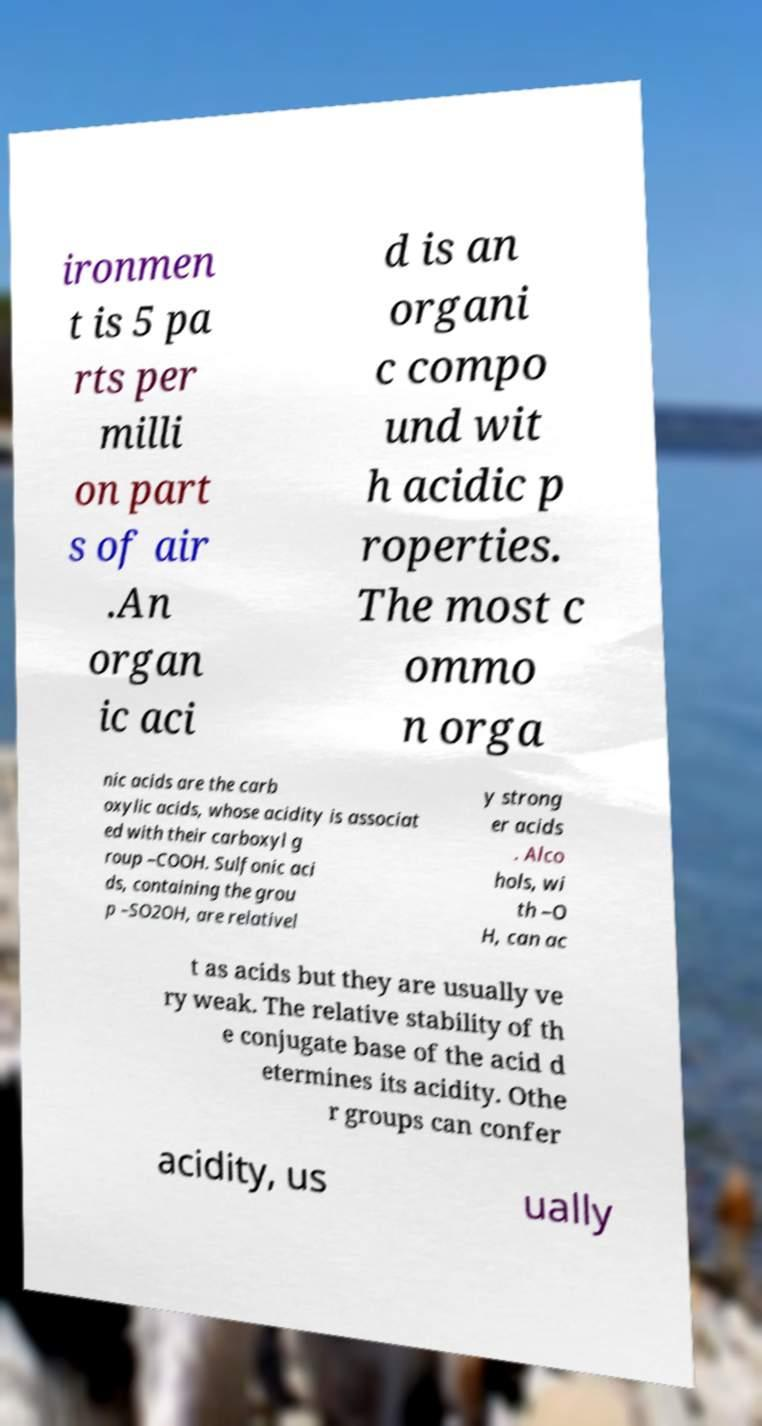For documentation purposes, I need the text within this image transcribed. Could you provide that? ironmen t is 5 pa rts per milli on part s of air .An organ ic aci d is an organi c compo und wit h acidic p roperties. The most c ommo n orga nic acids are the carb oxylic acids, whose acidity is associat ed with their carboxyl g roup –COOH. Sulfonic aci ds, containing the grou p –SO2OH, are relativel y strong er acids . Alco hols, wi th –O H, can ac t as acids but they are usually ve ry weak. The relative stability of th e conjugate base of the acid d etermines its acidity. Othe r groups can confer acidity, us ually 